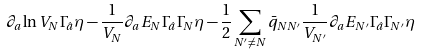<formula> <loc_0><loc_0><loc_500><loc_500>\partial _ { a } \ln V _ { N } \Gamma _ { \hat { a } } \eta - \frac { 1 } { V _ { N } } \partial _ { a } E _ { N } \Gamma _ { \hat { a } } \Gamma _ { N } \eta - \frac { 1 } { 2 } \sum _ { N ^ { \prime } \neq N } \bar { q } _ { N N ^ { \prime } } \frac { 1 } { V _ { N ^ { \prime } } } \partial _ { a } E _ { N ^ { \prime } } \Gamma _ { \hat { a } } \Gamma _ { N ^ { \prime } } \eta</formula> 